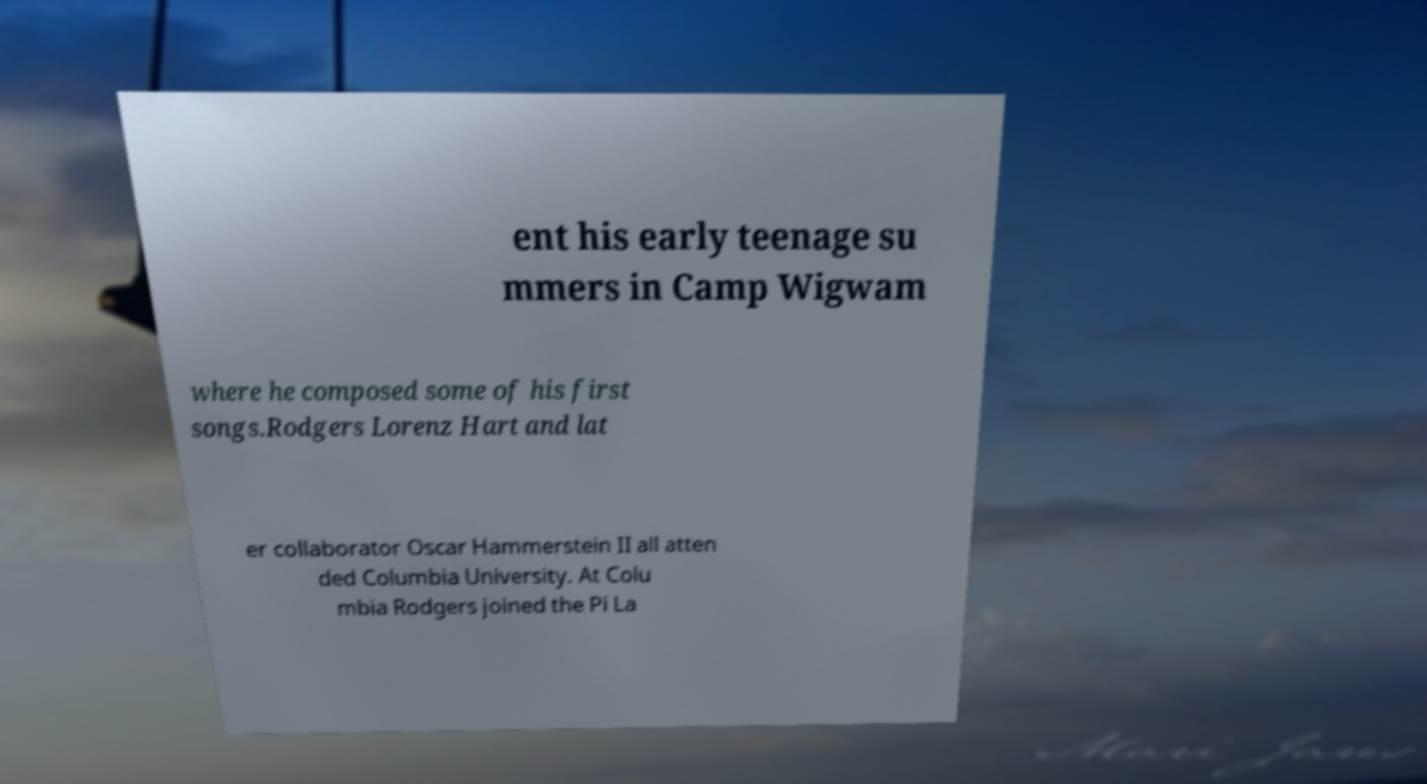What messages or text are displayed in this image? I need them in a readable, typed format. ent his early teenage su mmers in Camp Wigwam where he composed some of his first songs.Rodgers Lorenz Hart and lat er collaborator Oscar Hammerstein II all atten ded Columbia University. At Colu mbia Rodgers joined the Pi La 